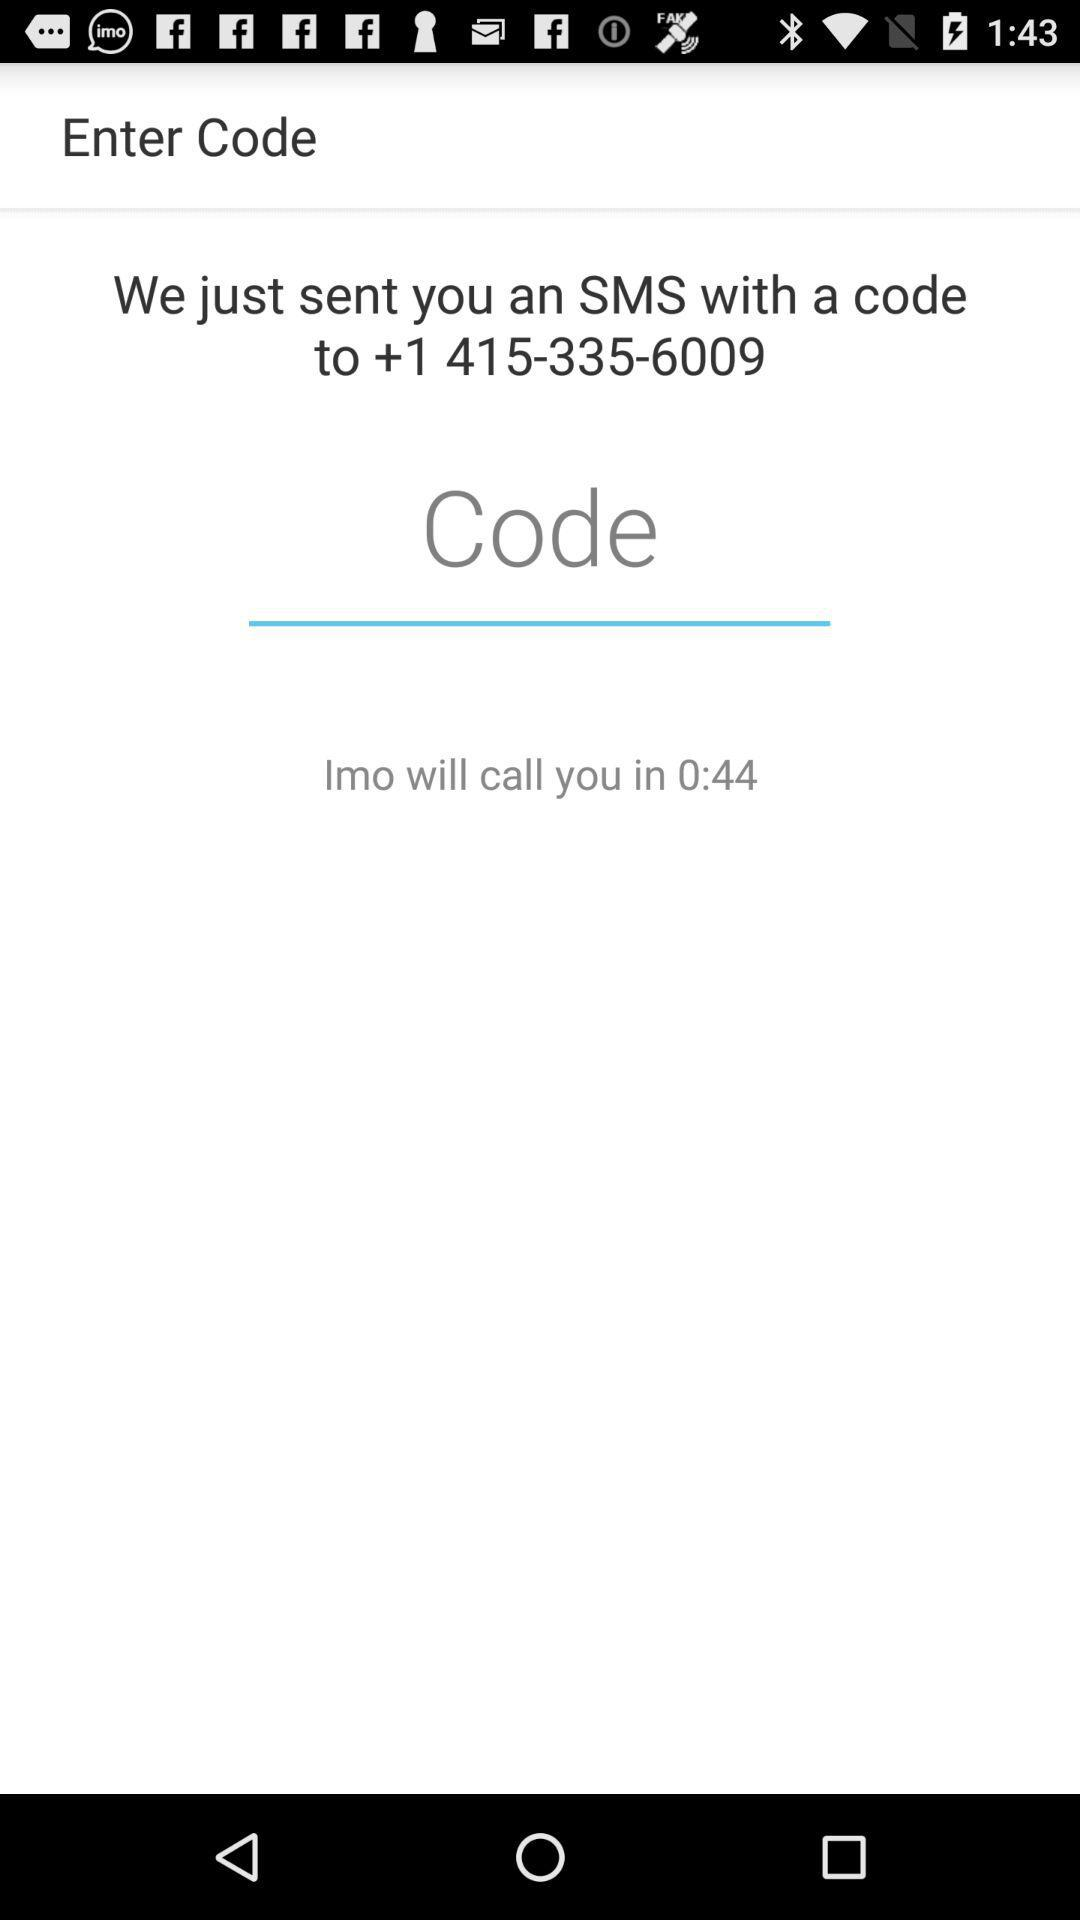What is the code?
When the provided information is insufficient, respond with <no answer>. <no answer> 